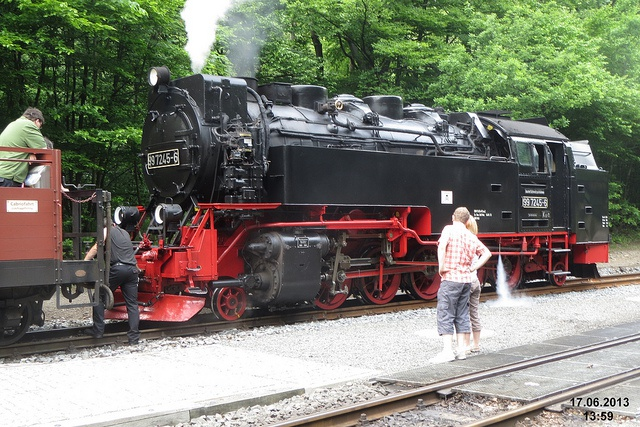Describe the objects in this image and their specific colors. I can see train in black, gray, maroon, and darkgray tones, people in black, white, darkgray, lightpink, and gray tones, people in black and gray tones, people in black, beige, gray, lightgreen, and darkgray tones, and people in black, lightgray, darkgray, and gray tones in this image. 